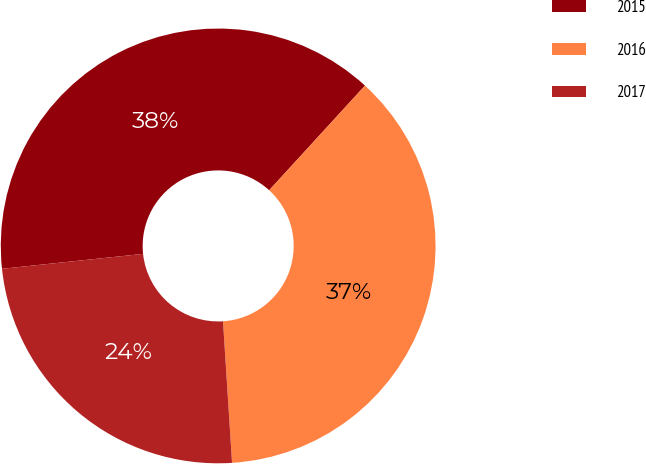<chart> <loc_0><loc_0><loc_500><loc_500><pie_chart><fcel>2015<fcel>2016<fcel>2017<nl><fcel>38.48%<fcel>37.18%<fcel>24.34%<nl></chart> 